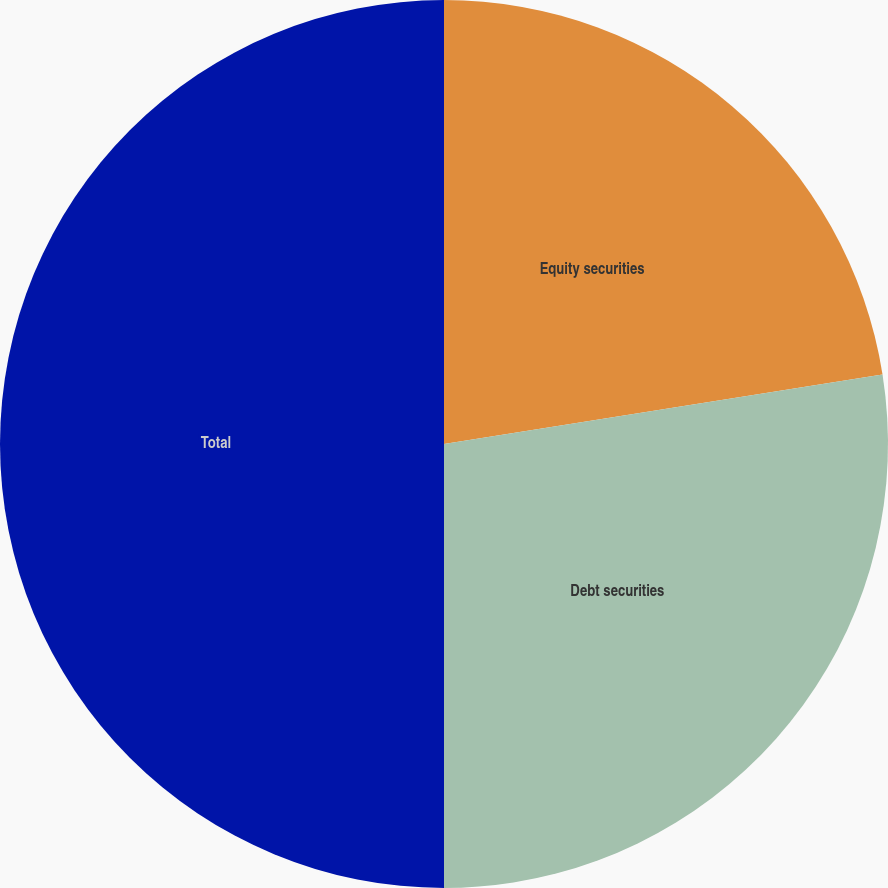Convert chart. <chart><loc_0><loc_0><loc_500><loc_500><pie_chart><fcel>Equity securities<fcel>Debt securities<fcel>Total<nl><fcel>22.5%<fcel>27.5%<fcel>50.0%<nl></chart> 